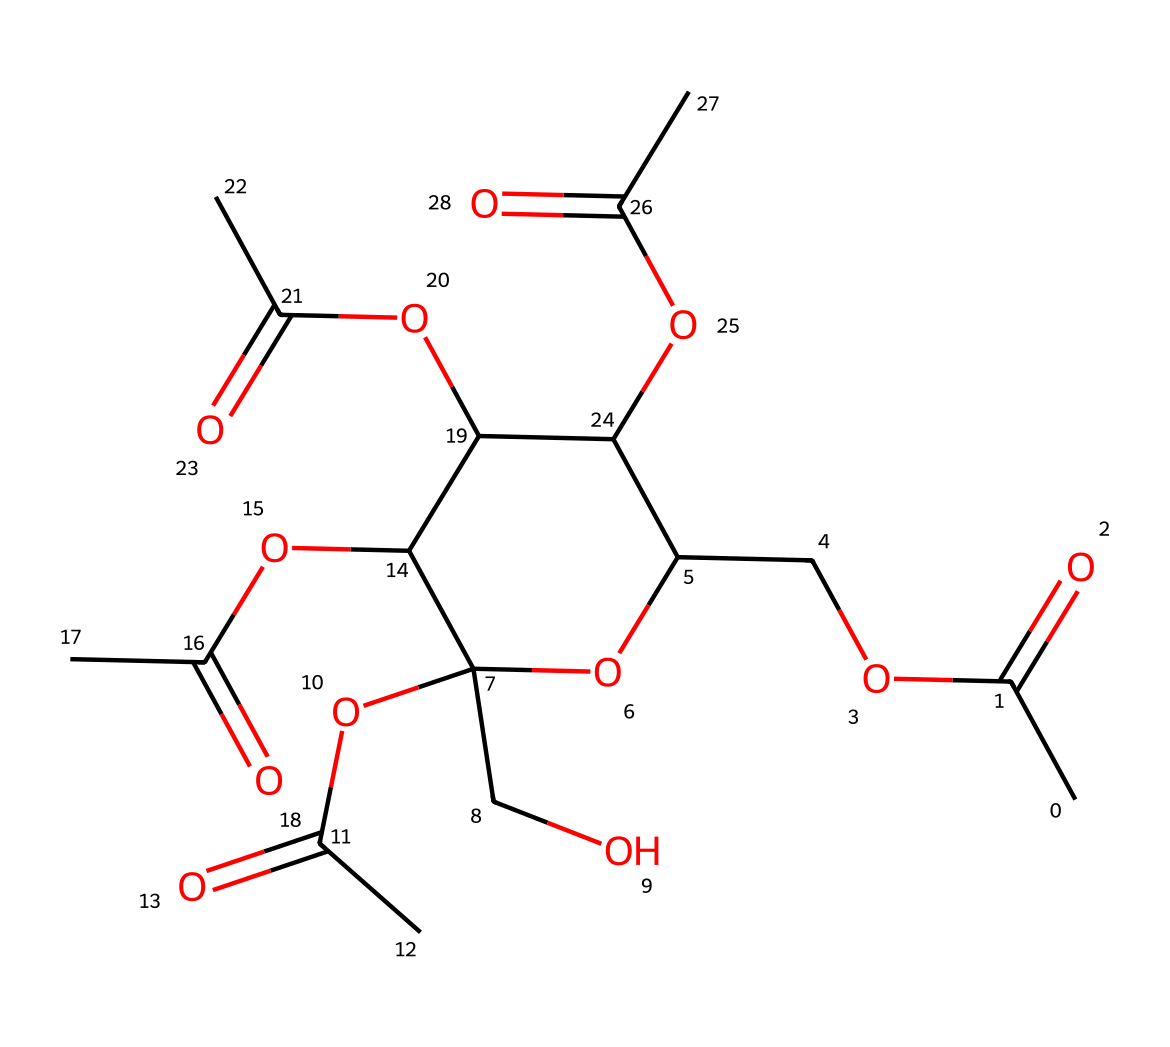What is the molecular formula of cellulose acetate based on this structure? By analyzing the SMILES representation, we can count the different types of atoms present. The structure contains carbon (C), hydrogen (H), and oxygen (O) atoms. Specifically, there are 12 carbons, 18 hydrogens, and 6 oxygens, leading to the molecular formula C12H18O6.
Answer: C12H18O6 How many rings are present in the molecular structure? The representation shows a cyclic structure indicated by the 'C1' in the SMILES, which denotes the start and end of a ring. Here, there is one ring known as a sugar ring within the cellulose acetate structure.
Answer: 1 What type of functional groups are present in cellulose acetate? The SMILES notation includes the 'CC(=O)' parts, which indicate acetyl groups (–C(=O)–). Additionally, there are ether linkages represented by 'O' connections in the structure. Therefore, the functional groups present are acetyl groups and ether groups.
Answer: acetyl and ether Does this structure allow for hydrogen bonding? The presence of hydroxyl groups ( –OH ) in the chemical structure suggests that hydrogen bonding can occur between these groups and other molecules, such as water. Therefore, the answer is affirmative.
Answer: yes What is the primary role of cellulose acetate in early film reels? Cellulose acetate served as a base film material due to its flexibility and transparency, which were essential for film production. Additionally, it provides a safer alternative compared to nitrate film, which is flammable.
Answer: film base What aspect of cellulose acetate contributes to its biodegradability? The acetic acid functional groups allow cellulose acetate to be broken down by microbial action, unlike non-biodegradable compounds. The presence of oxygen in functional groups is key for biodegradation.
Answer: acetic acid groups 